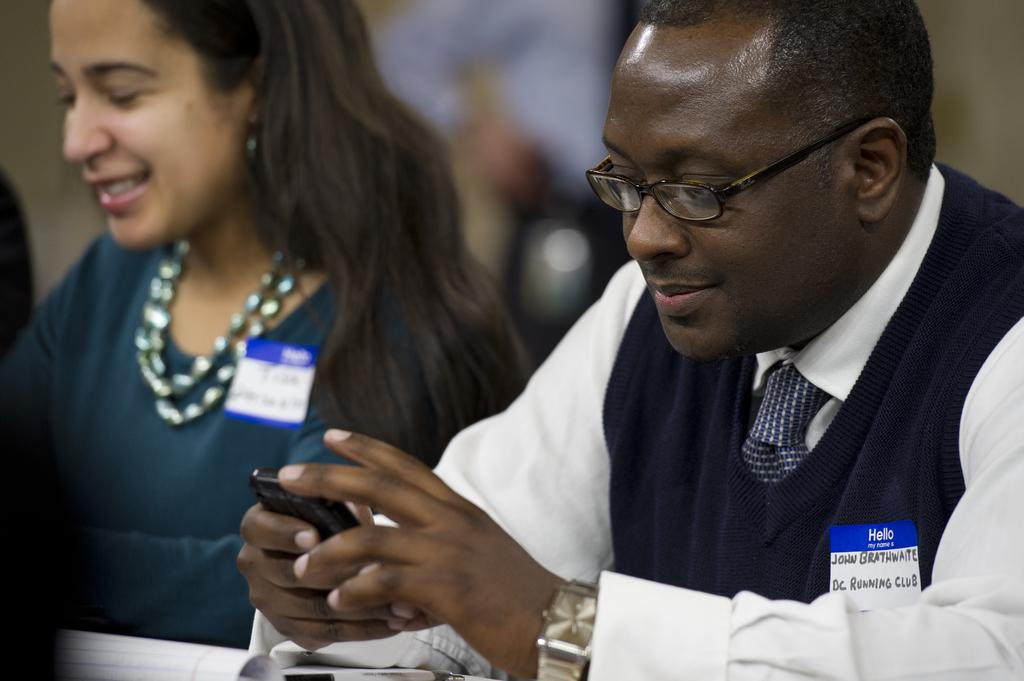Where was the image taken? The image was taken inside a room. Who is present in the image? There is a man and a woman in the image. What is the man holding in his hand? The man is holding a mobile in his hand. On which sides of the image are the man and woman located? The man is on the right side of the image, and the woman is on the left side of the image. Can you see a rabbit resting on the man's thumb in the image? No, there is no rabbit or any other animal present in the image. 